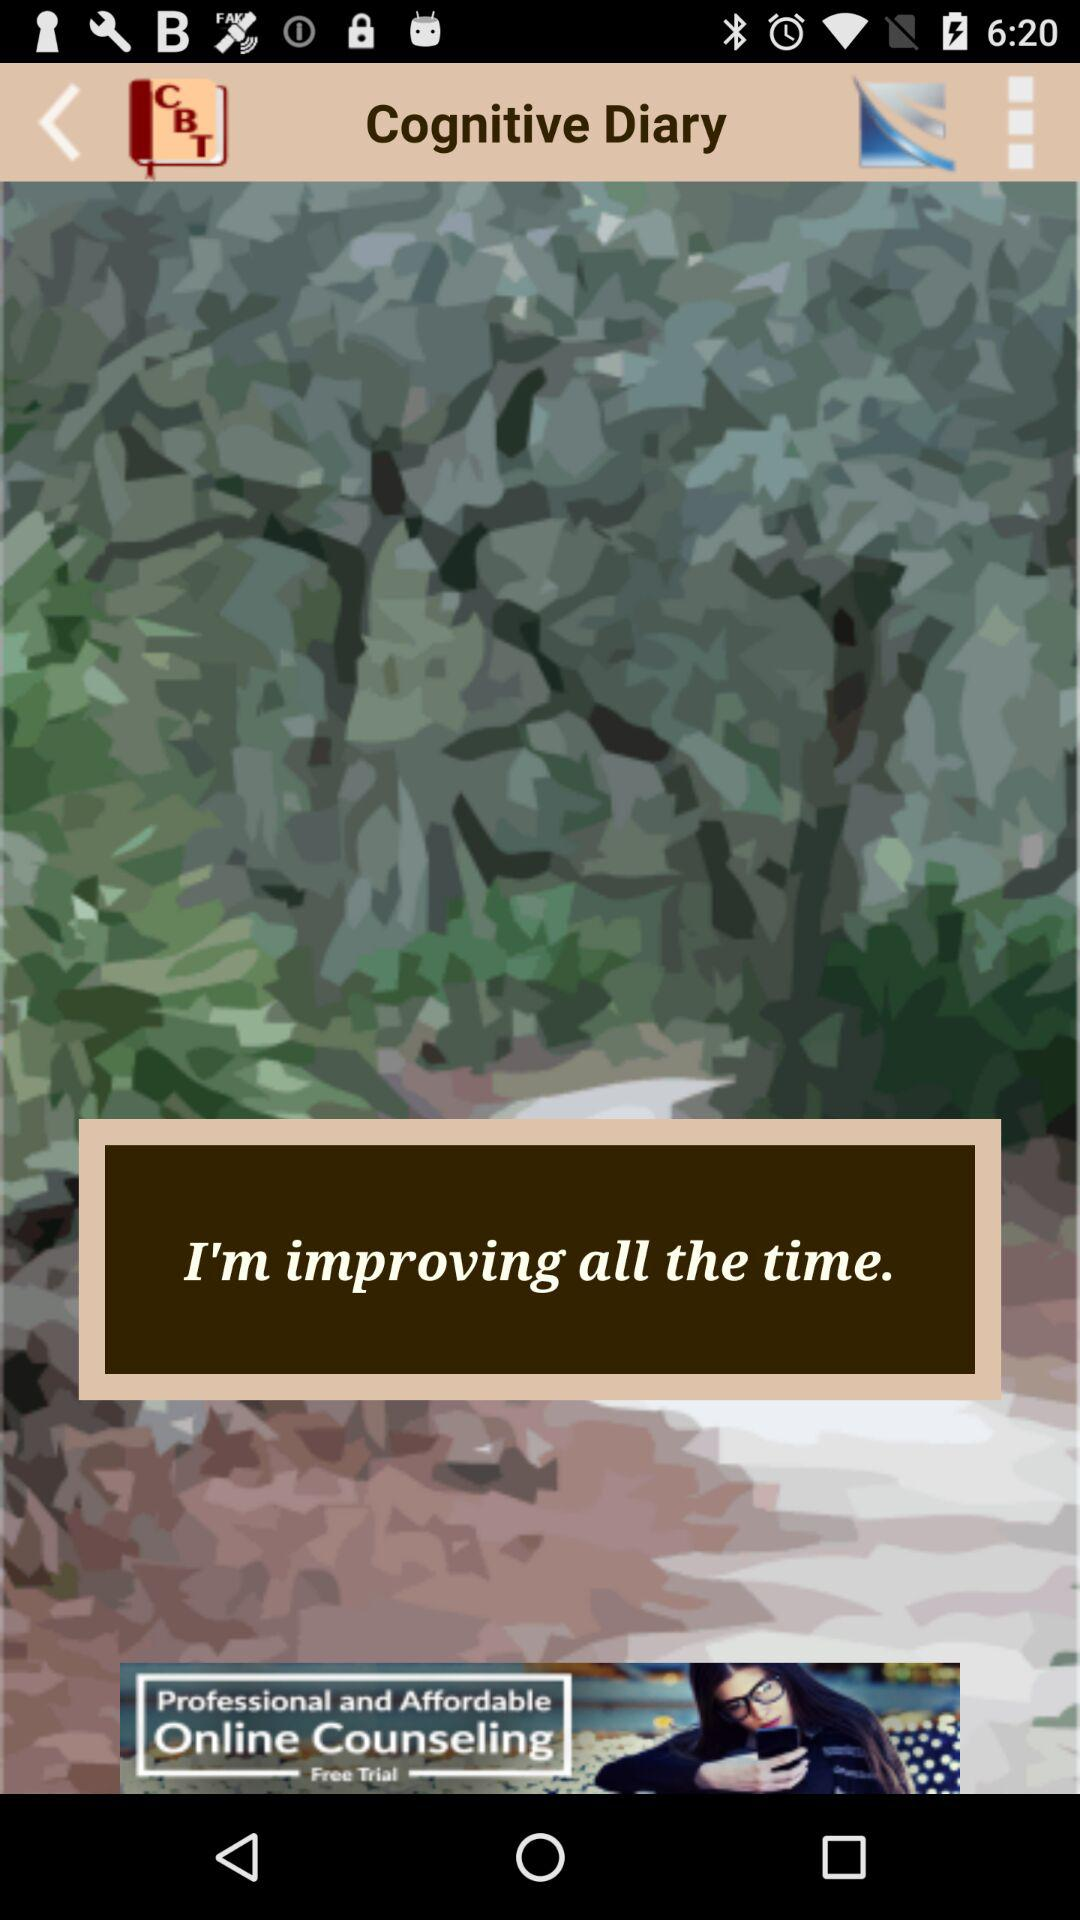What is the application name? The application name is "CBT Tools for Healthy Living". 